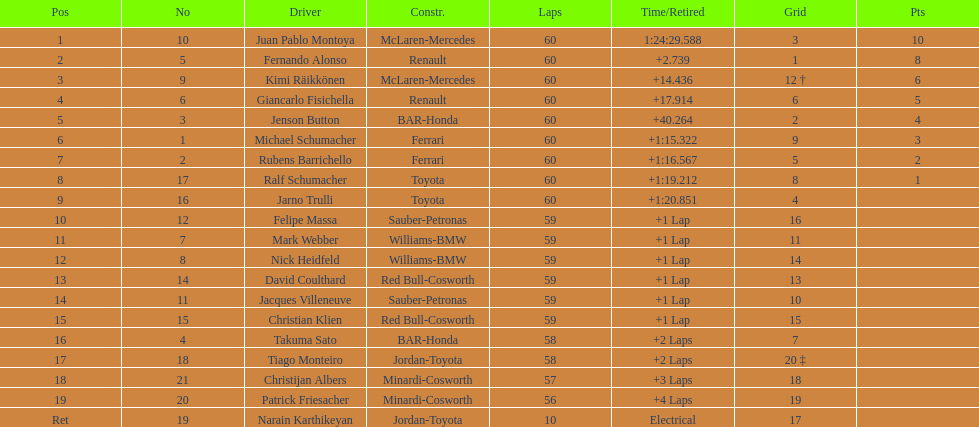Which driver has the least amount of points? Ralf Schumacher. 